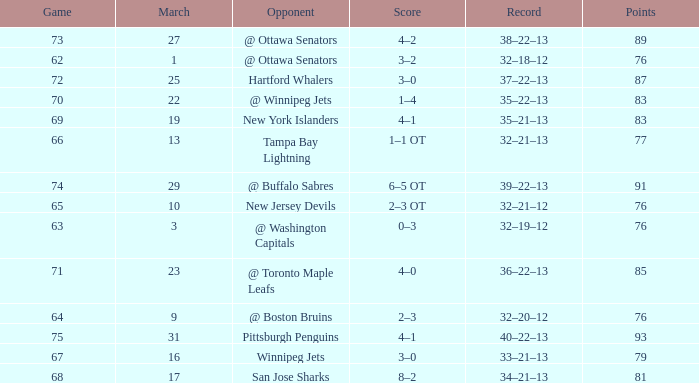Can you give me this table as a dict? {'header': ['Game', 'March', 'Opponent', 'Score', 'Record', 'Points'], 'rows': [['73', '27', '@ Ottawa Senators', '4–2', '38–22–13', '89'], ['62', '1', '@ Ottawa Senators', '3–2', '32–18–12', '76'], ['72', '25', 'Hartford Whalers', '3–0', '37–22–13', '87'], ['70', '22', '@ Winnipeg Jets', '1–4', '35–22–13', '83'], ['69', '19', 'New York Islanders', '4–1', '35–21–13', '83'], ['66', '13', 'Tampa Bay Lightning', '1–1 OT', '32–21–13', '77'], ['74', '29', '@ Buffalo Sabres', '6–5 OT', '39–22–13', '91'], ['65', '10', 'New Jersey Devils', '2–3 OT', '32–21–12', '76'], ['63', '3', '@ Washington Capitals', '0–3', '32–19–12', '76'], ['71', '23', '@ Toronto Maple Leafs', '4–0', '36–22–13', '85'], ['64', '9', '@ Boston Bruins', '2–3', '32–20–12', '76'], ['75', '31', 'Pittsburgh Penguins', '4–1', '40–22–13', '93'], ['67', '16', 'Winnipeg Jets', '3–0', '33–21–13', '79'], ['68', '17', 'San Jose Sharks', '8–2', '34–21–13', '81']]} How much March has Points of 85? 1.0. 